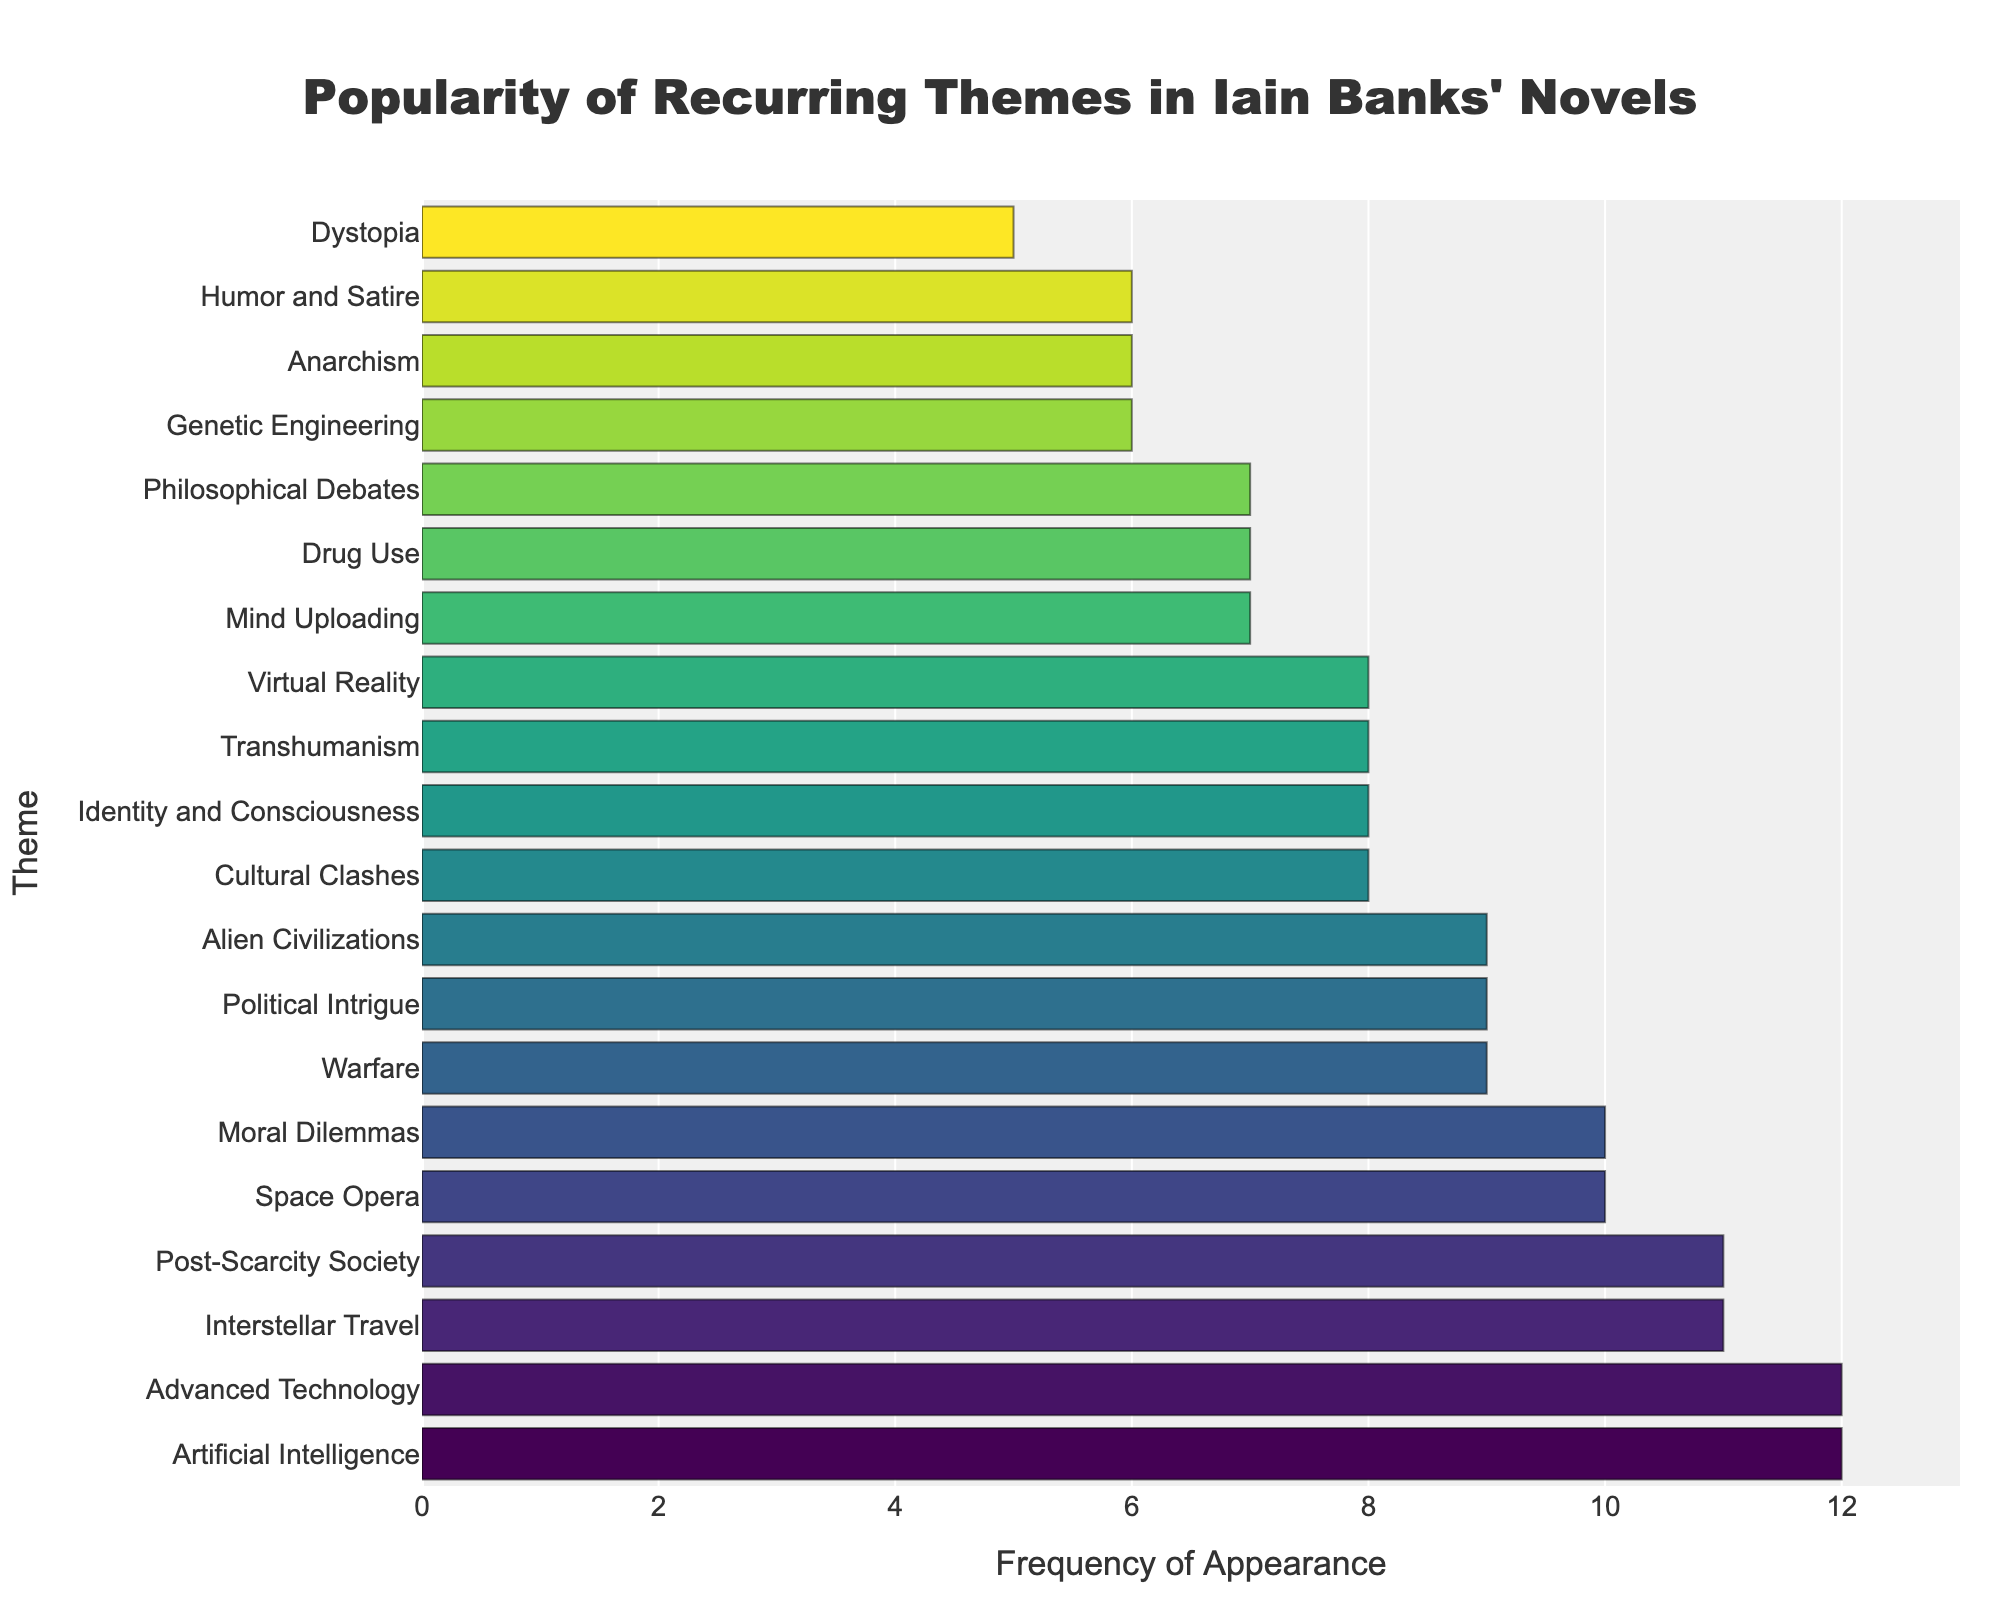What theme appears the most frequently in Iain Banks' novels? The theme with the highest bar indicates the greatest frequency. In this case, the themes "Artificial Intelligence" and "Advanced Technology" both have the highest bar lengths, each appearing 12 times.
Answer: Artificial Intelligence and Advanced Technology Which themes appear exactly 6 times in the novels? By examining the lengths of the bars, we can identify that "Anarchism," "Genetic Engineering," and "Humor and Satire" each have bars corresponding to the frequency of 6.
Answer: Anarchism, Genetic Engineering, Humor and Satire What is the difference in frequency between the most common theme and the least common theme? The most common themes, "Artificial Intelligence" and "Advanced Technology," appear 12 times each, while the least common theme, "Dystopia," appears 5 times. The difference is calculated as 12 - 5 = 7.
Answer: 7 How many themes have a frequency of 8 or higher? Counting the bars that have a length corresponding to a frequency of 8 or more, we identify the following themes: "Artificial Intelligence" (12), "Advanced Technology" (12), "Post-Scarcity Society" (11), "Interstellar Travel" (11), "Space Opera" (10), "Moral Dilemmas" (10), "Political Intrigue" (9), "Alien Civilizations" (9), "Warfare" (9), "Virtual Reality" (8), "Transhumanism" (8), "Cultural Clashes" (8), "Identity and Consciousness" (8). This sums up to 13 themes.
Answer: 13 Which themes have a frequency greater than "Drug Use" but less than "Space Opera"? The frequency of "Drug Use" is 7, and the frequency of "Space Opera" is 10. Therefore, the themes with frequencies greater than 7 but less than 10 are "Political Intrigue," "Alien Civilizations," "Warfare," "Virtual Reality," "Transhumanism," "Cultural Clashes," and "Identity and Consciousness," all of which have a frequency of 8 or 9.
Answer: Political Intrigue, Alien Civilizations, Warfare, Virtual Reality, Transhumanism, Cultural Clashes, Identity and Consciousness What is the median frequency of all themes? To find the median frequency, list all frequencies in ascending order: [5, 6, 6, 6, 7, 7, 7, 7, 8, 8, 8, 8, 8, 8, 9, 9, 9, 10, 10, 11, 11, 12, 12]. The median value in an odd-length list is the middle number. Here the list has 23 numbers, so the median is the 12th number in the ordered list, which is 8.
Answer: 8 How many themes are represented in the chart? Each bar represents a distinct theme. Counting the total number of bars gives us the total number of themes. There are 20 bars, so there are 20 themes.
Answer: 20 Which theme related to societal constructs has the highest frequency? Societal constructs within the themes include "Anarchism," "Post-Scarcity Society," "Dystopia," and "Political Intrigue." Among these, "Post-Scarcity Society" has the highest frequency at 11.
Answer: Post-Scarcity Society Which theme is represented by the longest bar? The longest bars correspond to the highest frequencies, which are 12 in this chart. Both "Artificial Intelligence" and "Advanced Technology" share this frequency and thus have the longest bars.
Answer: Artificial Intelligence and Advanced Technology 